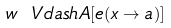<formula> <loc_0><loc_0><loc_500><loc_500>w \ V d a s h A [ e ( x \to a ) ]</formula> 